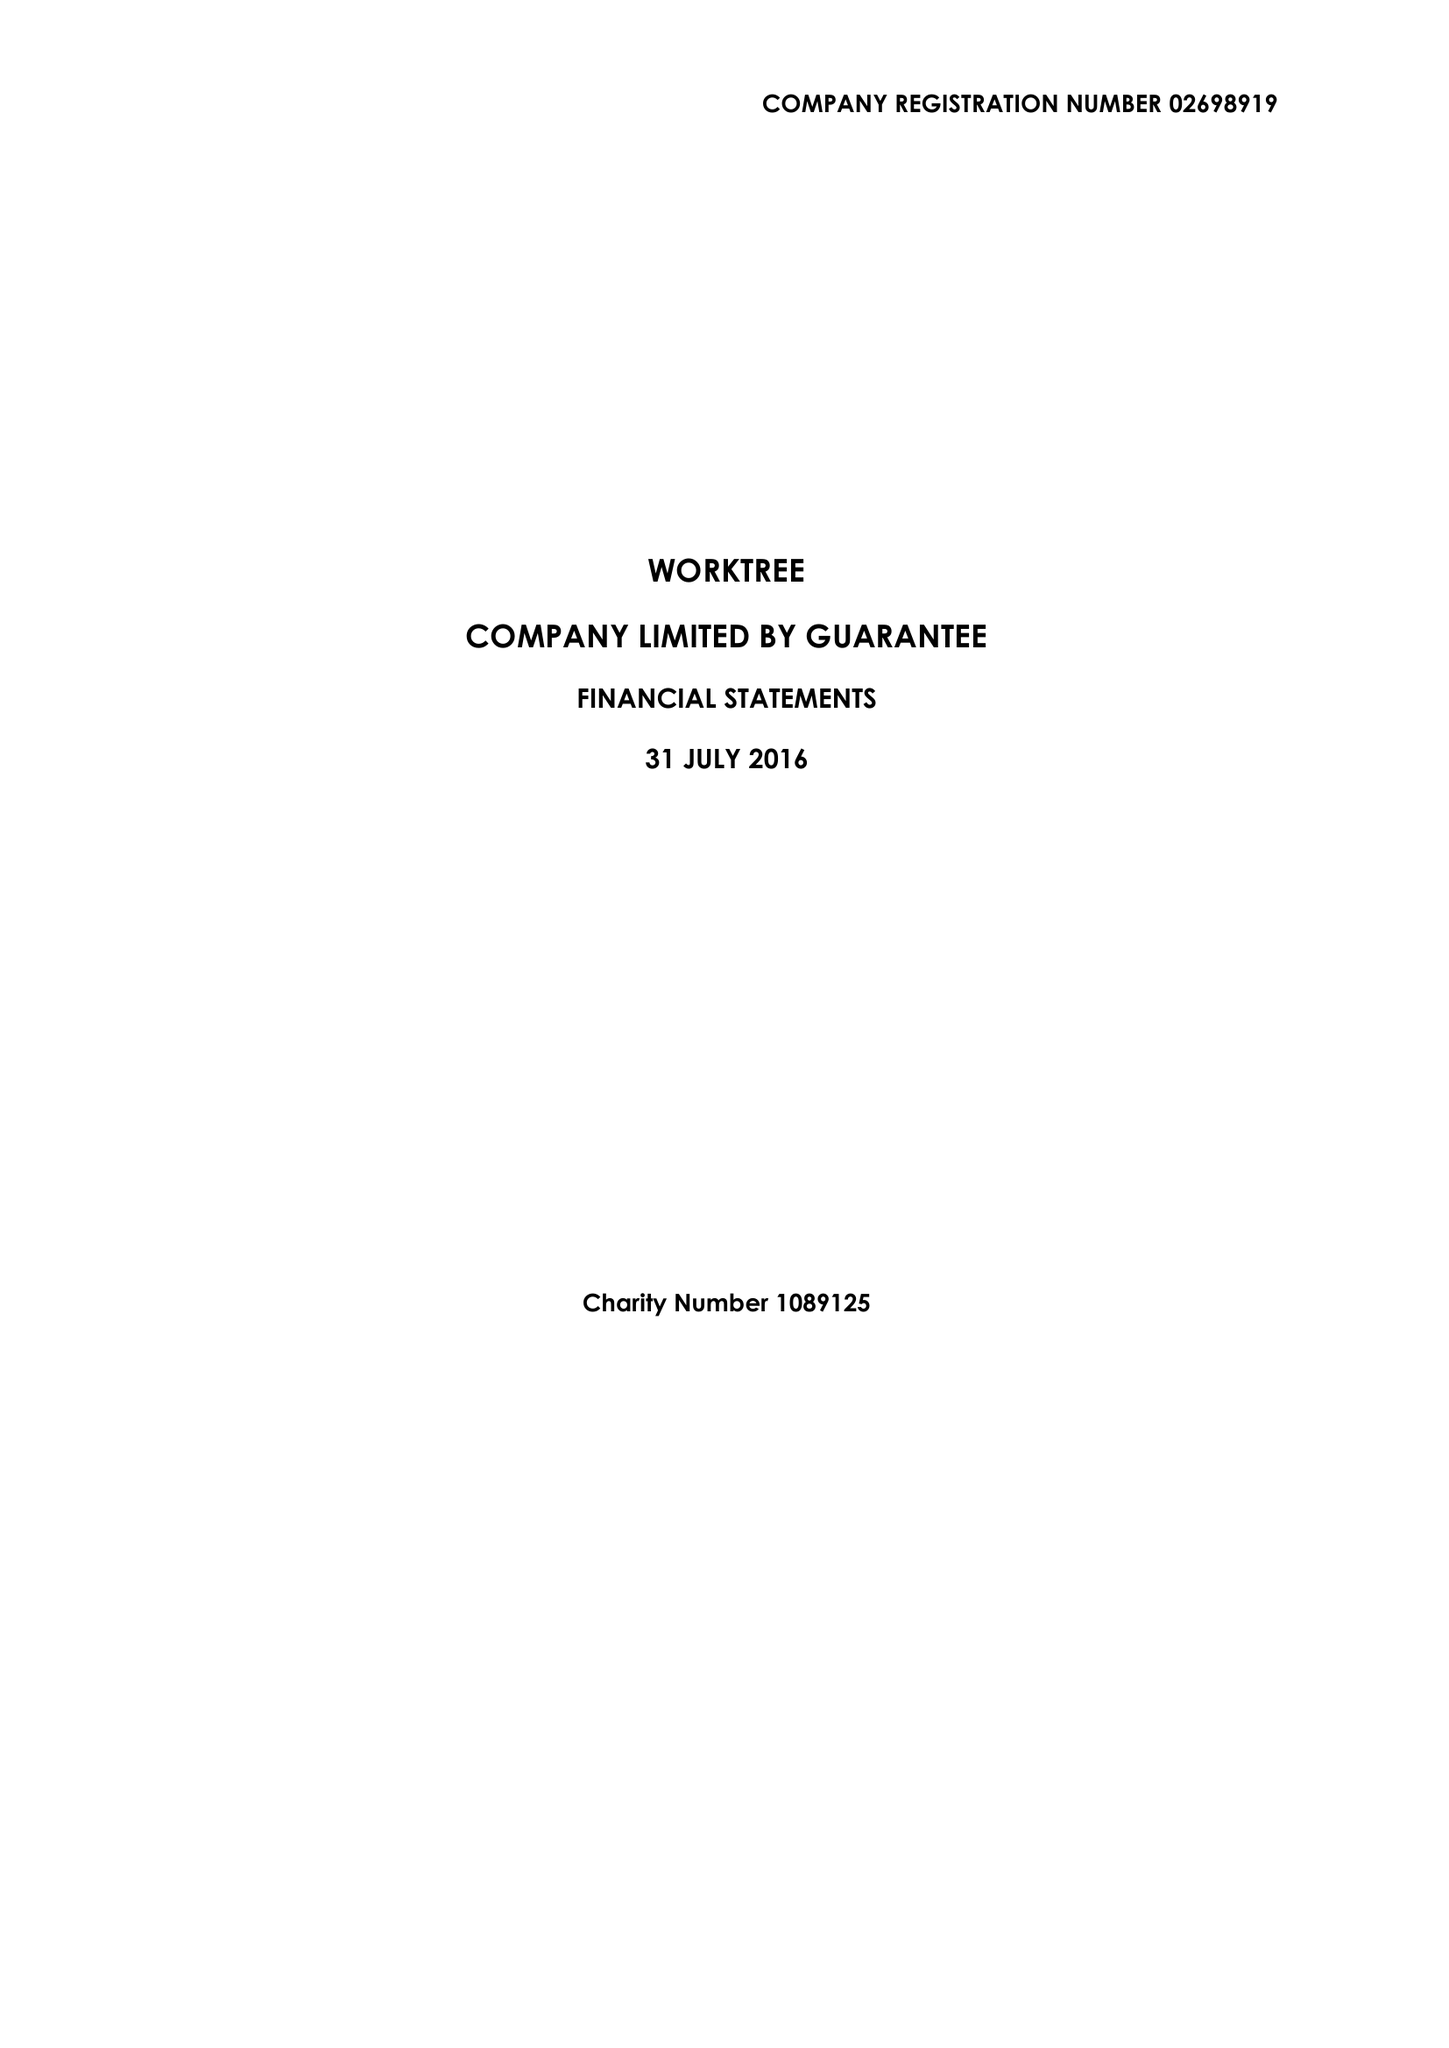What is the value for the address__post_town?
Answer the question using a single word or phrase. MILTON KEYNES 